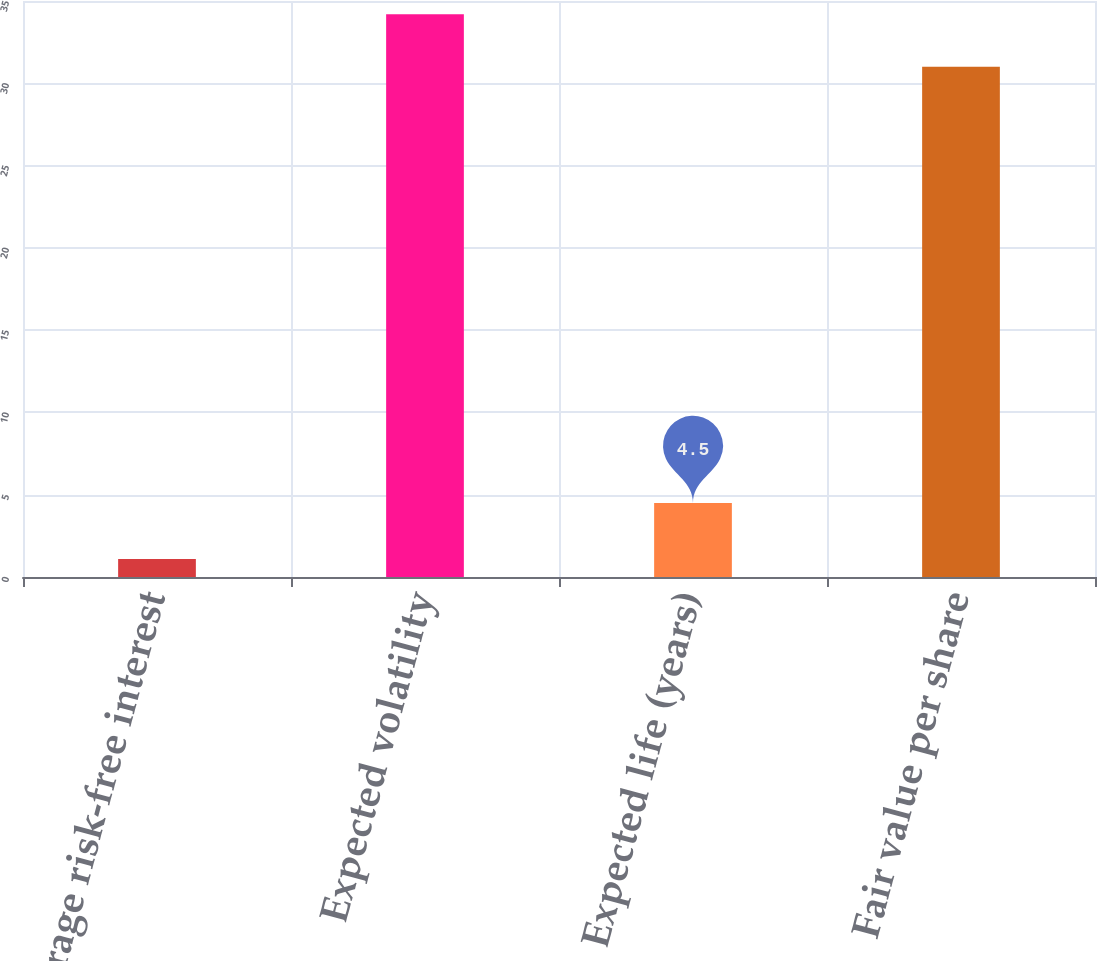Convert chart to OTSL. <chart><loc_0><loc_0><loc_500><loc_500><bar_chart><fcel>Average risk-free interest<fcel>Expected volatility<fcel>Expected life (years)<fcel>Fair value per share<nl><fcel>1.1<fcel>34.19<fcel>4.5<fcel>31<nl></chart> 